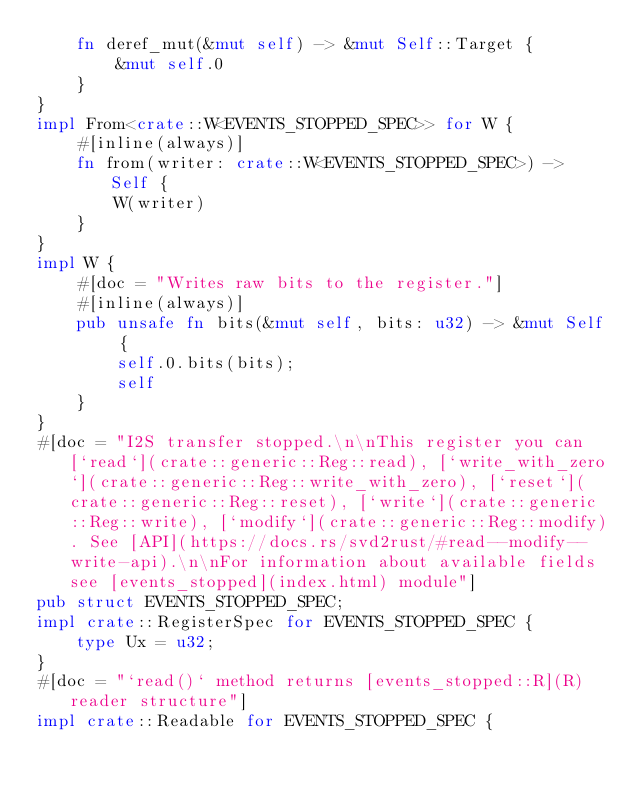Convert code to text. <code><loc_0><loc_0><loc_500><loc_500><_Rust_>    fn deref_mut(&mut self) -> &mut Self::Target {
        &mut self.0
    }
}
impl From<crate::W<EVENTS_STOPPED_SPEC>> for W {
    #[inline(always)]
    fn from(writer: crate::W<EVENTS_STOPPED_SPEC>) -> Self {
        W(writer)
    }
}
impl W {
    #[doc = "Writes raw bits to the register."]
    #[inline(always)]
    pub unsafe fn bits(&mut self, bits: u32) -> &mut Self {
        self.0.bits(bits);
        self
    }
}
#[doc = "I2S transfer stopped.\n\nThis register you can [`read`](crate::generic::Reg::read), [`write_with_zero`](crate::generic::Reg::write_with_zero), [`reset`](crate::generic::Reg::reset), [`write`](crate::generic::Reg::write), [`modify`](crate::generic::Reg::modify). See [API](https://docs.rs/svd2rust/#read--modify--write-api).\n\nFor information about available fields see [events_stopped](index.html) module"]
pub struct EVENTS_STOPPED_SPEC;
impl crate::RegisterSpec for EVENTS_STOPPED_SPEC {
    type Ux = u32;
}
#[doc = "`read()` method returns [events_stopped::R](R) reader structure"]
impl crate::Readable for EVENTS_STOPPED_SPEC {</code> 